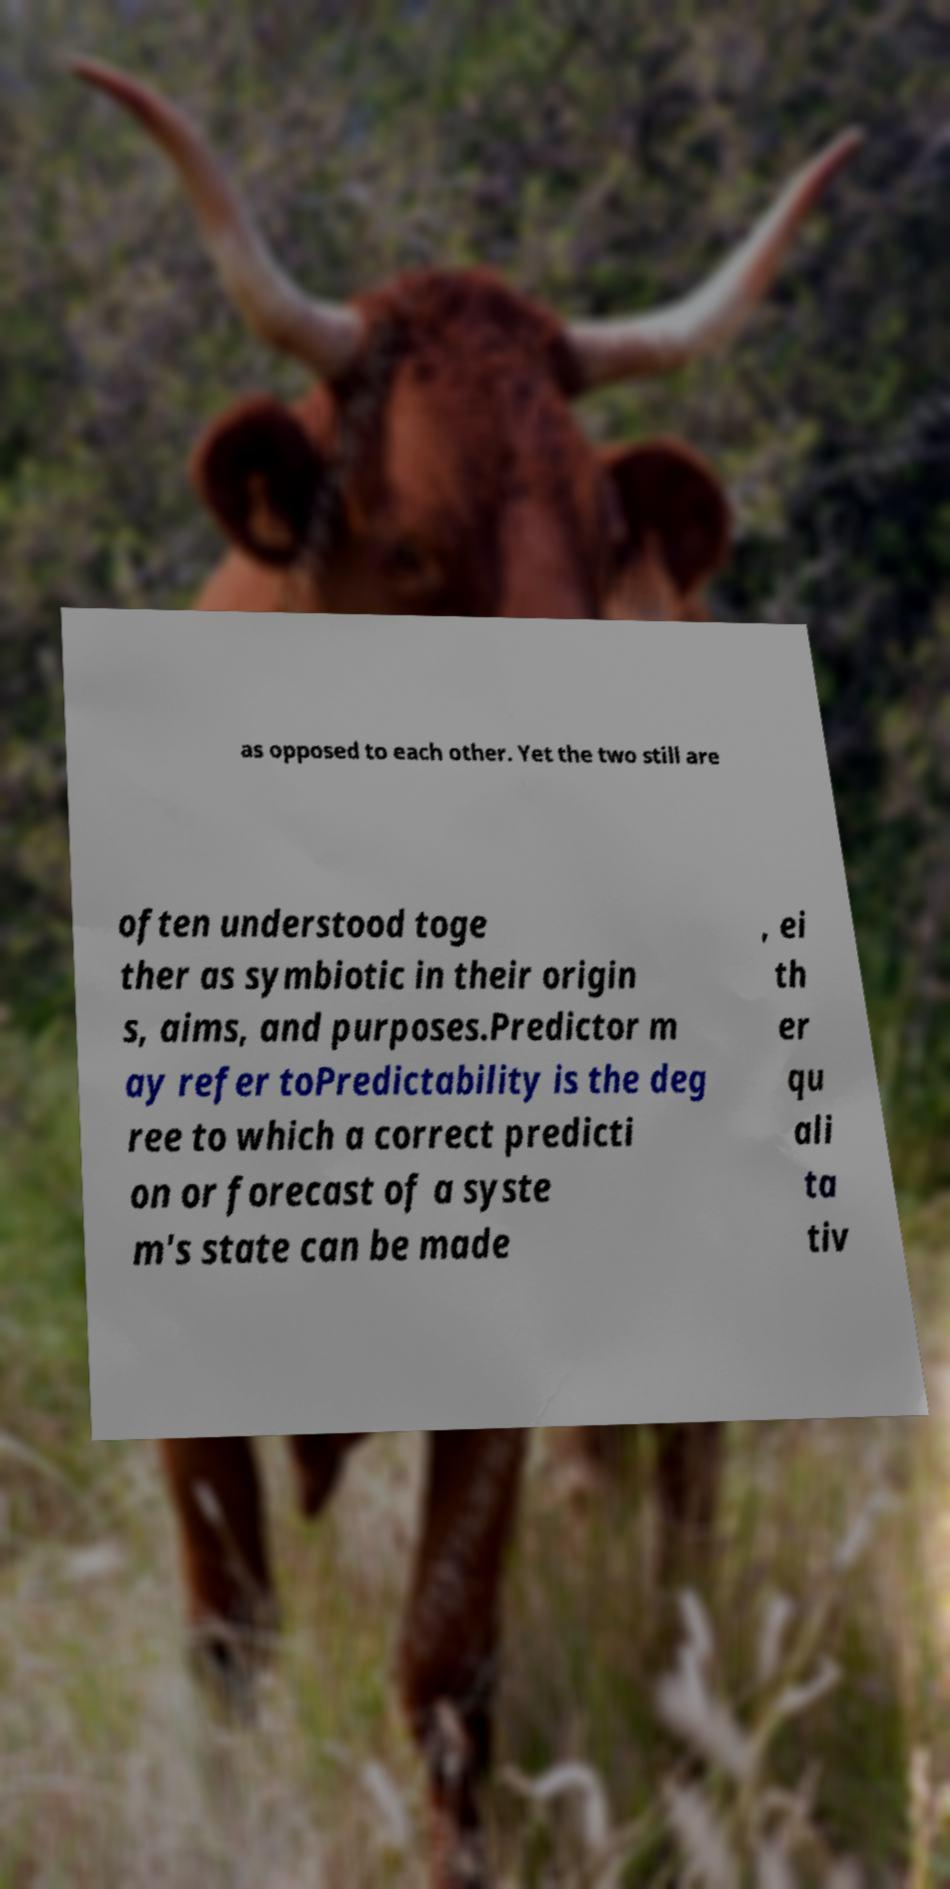For documentation purposes, I need the text within this image transcribed. Could you provide that? as opposed to each other. Yet the two still are often understood toge ther as symbiotic in their origin s, aims, and purposes.Predictor m ay refer toPredictability is the deg ree to which a correct predicti on or forecast of a syste m's state can be made , ei th er qu ali ta tiv 